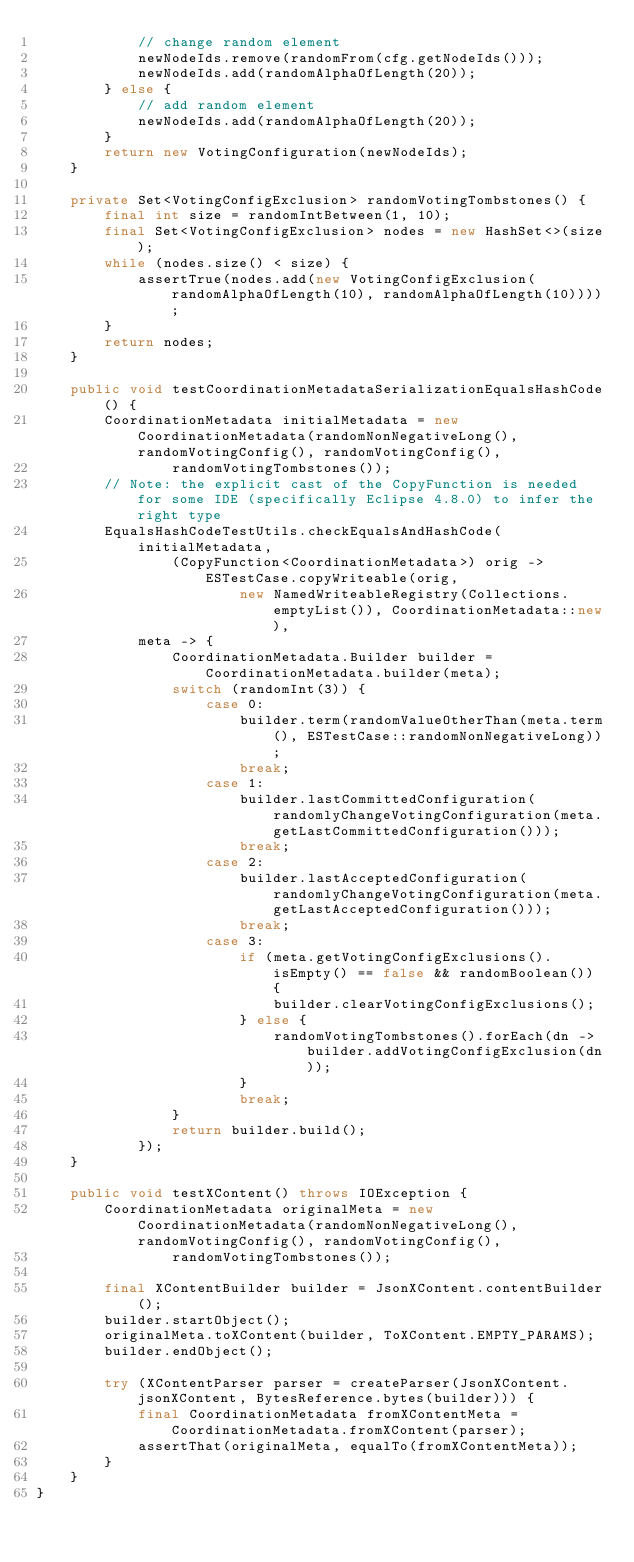Convert code to text. <code><loc_0><loc_0><loc_500><loc_500><_Java_>            // change random element
            newNodeIds.remove(randomFrom(cfg.getNodeIds()));
            newNodeIds.add(randomAlphaOfLength(20));
        } else {
            // add random element
            newNodeIds.add(randomAlphaOfLength(20));
        }
        return new VotingConfiguration(newNodeIds);
    }

    private Set<VotingConfigExclusion> randomVotingTombstones() {
        final int size = randomIntBetween(1, 10);
        final Set<VotingConfigExclusion> nodes = new HashSet<>(size);
        while (nodes.size() < size) {
            assertTrue(nodes.add(new VotingConfigExclusion(randomAlphaOfLength(10), randomAlphaOfLength(10))));
        }
        return nodes;
    }

    public void testCoordinationMetadataSerializationEqualsHashCode() {
        CoordinationMetadata initialMetadata = new CoordinationMetadata(randomNonNegativeLong(), randomVotingConfig(), randomVotingConfig(),
                randomVotingTombstones());
        // Note: the explicit cast of the CopyFunction is needed for some IDE (specifically Eclipse 4.8.0) to infer the right type
        EqualsHashCodeTestUtils.checkEqualsAndHashCode(initialMetadata,
                (CopyFunction<CoordinationMetadata>) orig -> ESTestCase.copyWriteable(orig,
                        new NamedWriteableRegistry(Collections.emptyList()), CoordinationMetadata::new),
            meta -> {
                CoordinationMetadata.Builder builder = CoordinationMetadata.builder(meta);
                switch (randomInt(3)) {
                    case 0:
                        builder.term(randomValueOtherThan(meta.term(), ESTestCase::randomNonNegativeLong));
                        break;
                    case 1:
                        builder.lastCommittedConfiguration(randomlyChangeVotingConfiguration(meta.getLastCommittedConfiguration()));
                        break;
                    case 2:
                        builder.lastAcceptedConfiguration(randomlyChangeVotingConfiguration(meta.getLastAcceptedConfiguration()));
                        break;
                    case 3:
                        if (meta.getVotingConfigExclusions().isEmpty() == false && randomBoolean()) {
                            builder.clearVotingConfigExclusions();
                        } else {
                            randomVotingTombstones().forEach(dn -> builder.addVotingConfigExclusion(dn));
                        }
                        break;
                }
                return builder.build();
            });
    }

    public void testXContent() throws IOException {
        CoordinationMetadata originalMeta = new CoordinationMetadata(randomNonNegativeLong(), randomVotingConfig(), randomVotingConfig(),
                randomVotingTombstones());

        final XContentBuilder builder = JsonXContent.contentBuilder();
        builder.startObject();
        originalMeta.toXContent(builder, ToXContent.EMPTY_PARAMS);
        builder.endObject();

        try (XContentParser parser = createParser(JsonXContent.jsonXContent, BytesReference.bytes(builder))) {
            final CoordinationMetadata fromXContentMeta = CoordinationMetadata.fromXContent(parser);
            assertThat(originalMeta, equalTo(fromXContentMeta));
        }
    }
}
</code> 